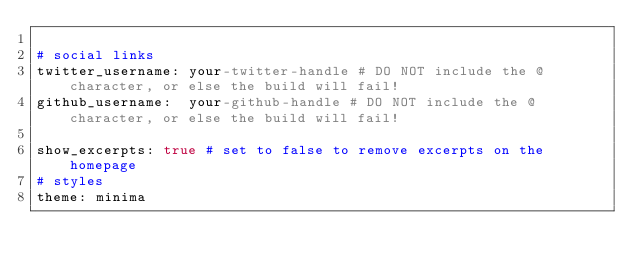<code> <loc_0><loc_0><loc_500><loc_500><_YAML_>
# social links
twitter_username: your-twitter-handle # DO NOT include the @ character, or else the build will fail!
github_username:  your-github-handle # DO NOT include the @ character, or else the build will fail!

show_excerpts: true # set to false to remove excerpts on the homepage
# styles
theme: minima
</code> 